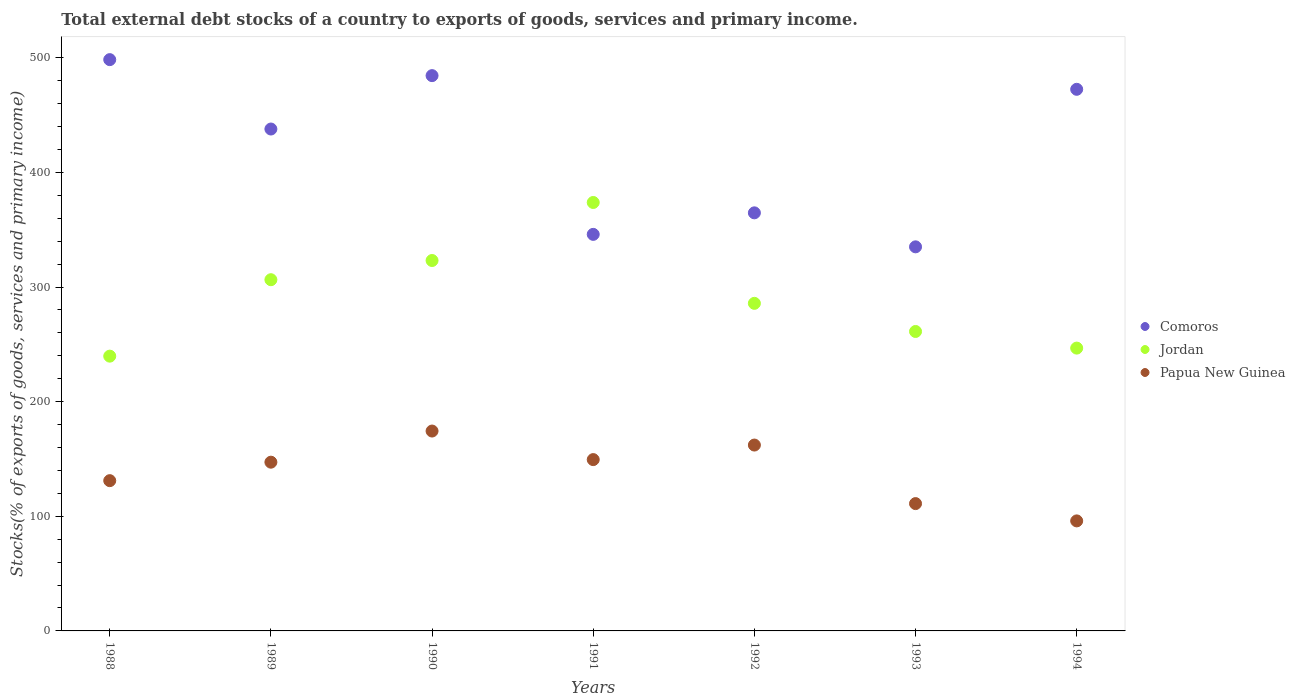How many different coloured dotlines are there?
Provide a short and direct response. 3. What is the total debt stocks in Papua New Guinea in 1994?
Provide a short and direct response. 95.99. Across all years, what is the maximum total debt stocks in Papua New Guinea?
Offer a very short reply. 174.38. Across all years, what is the minimum total debt stocks in Papua New Guinea?
Provide a short and direct response. 95.99. In which year was the total debt stocks in Comoros maximum?
Provide a succinct answer. 1988. In which year was the total debt stocks in Jordan minimum?
Your answer should be compact. 1988. What is the total total debt stocks in Comoros in the graph?
Your response must be concise. 2939.1. What is the difference between the total debt stocks in Comoros in 1992 and that in 1993?
Your response must be concise. 29.66. What is the difference between the total debt stocks in Jordan in 1993 and the total debt stocks in Papua New Guinea in 1988?
Keep it short and to the point. 130.15. What is the average total debt stocks in Jordan per year?
Your answer should be compact. 290.98. In the year 1993, what is the difference between the total debt stocks in Papua New Guinea and total debt stocks in Comoros?
Provide a short and direct response. -224.01. In how many years, is the total debt stocks in Jordan greater than 180 %?
Your answer should be very brief. 7. What is the ratio of the total debt stocks in Jordan in 1988 to that in 1990?
Ensure brevity in your answer.  0.74. Is the total debt stocks in Jordan in 1991 less than that in 1994?
Provide a short and direct response. No. What is the difference between the highest and the second highest total debt stocks in Papua New Guinea?
Keep it short and to the point. 12.22. What is the difference between the highest and the lowest total debt stocks in Jordan?
Give a very brief answer. 134.06. Is the sum of the total debt stocks in Comoros in 1989 and 1992 greater than the maximum total debt stocks in Jordan across all years?
Ensure brevity in your answer.  Yes. Is the total debt stocks in Jordan strictly greater than the total debt stocks in Papua New Guinea over the years?
Keep it short and to the point. Yes. Is the total debt stocks in Comoros strictly less than the total debt stocks in Jordan over the years?
Keep it short and to the point. No. How many years are there in the graph?
Your answer should be compact. 7. What is the difference between two consecutive major ticks on the Y-axis?
Give a very brief answer. 100. Are the values on the major ticks of Y-axis written in scientific E-notation?
Keep it short and to the point. No. Does the graph contain any zero values?
Provide a succinct answer. No. Where does the legend appear in the graph?
Keep it short and to the point. Center right. How are the legend labels stacked?
Offer a very short reply. Vertical. What is the title of the graph?
Your answer should be compact. Total external debt stocks of a country to exports of goods, services and primary income. Does "Pacific island small states" appear as one of the legend labels in the graph?
Make the answer very short. No. What is the label or title of the Y-axis?
Give a very brief answer. Stocks(% of exports of goods, services and primary income). What is the Stocks(% of exports of goods, services and primary income) in Comoros in 1988?
Offer a very short reply. 498.42. What is the Stocks(% of exports of goods, services and primary income) in Jordan in 1988?
Give a very brief answer. 239.73. What is the Stocks(% of exports of goods, services and primary income) in Papua New Guinea in 1988?
Provide a short and direct response. 131.1. What is the Stocks(% of exports of goods, services and primary income) of Comoros in 1989?
Offer a very short reply. 437.88. What is the Stocks(% of exports of goods, services and primary income) of Jordan in 1989?
Provide a succinct answer. 306.42. What is the Stocks(% of exports of goods, services and primary income) in Papua New Guinea in 1989?
Offer a very short reply. 147.21. What is the Stocks(% of exports of goods, services and primary income) in Comoros in 1990?
Your answer should be compact. 484.47. What is the Stocks(% of exports of goods, services and primary income) of Jordan in 1990?
Keep it short and to the point. 323.17. What is the Stocks(% of exports of goods, services and primary income) in Papua New Guinea in 1990?
Give a very brief answer. 174.38. What is the Stocks(% of exports of goods, services and primary income) in Comoros in 1991?
Ensure brevity in your answer.  345.97. What is the Stocks(% of exports of goods, services and primary income) of Jordan in 1991?
Ensure brevity in your answer.  373.79. What is the Stocks(% of exports of goods, services and primary income) in Papua New Guinea in 1991?
Offer a very short reply. 149.47. What is the Stocks(% of exports of goods, services and primary income) in Comoros in 1992?
Your answer should be very brief. 364.75. What is the Stocks(% of exports of goods, services and primary income) of Jordan in 1992?
Provide a succinct answer. 285.8. What is the Stocks(% of exports of goods, services and primary income) in Papua New Guinea in 1992?
Keep it short and to the point. 162.16. What is the Stocks(% of exports of goods, services and primary income) of Comoros in 1993?
Offer a terse response. 335.09. What is the Stocks(% of exports of goods, services and primary income) of Jordan in 1993?
Your answer should be compact. 261.25. What is the Stocks(% of exports of goods, services and primary income) of Papua New Guinea in 1993?
Your answer should be compact. 111.08. What is the Stocks(% of exports of goods, services and primary income) of Comoros in 1994?
Offer a very short reply. 472.53. What is the Stocks(% of exports of goods, services and primary income) of Jordan in 1994?
Provide a short and direct response. 246.74. What is the Stocks(% of exports of goods, services and primary income) of Papua New Guinea in 1994?
Make the answer very short. 95.99. Across all years, what is the maximum Stocks(% of exports of goods, services and primary income) of Comoros?
Make the answer very short. 498.42. Across all years, what is the maximum Stocks(% of exports of goods, services and primary income) in Jordan?
Give a very brief answer. 373.79. Across all years, what is the maximum Stocks(% of exports of goods, services and primary income) in Papua New Guinea?
Give a very brief answer. 174.38. Across all years, what is the minimum Stocks(% of exports of goods, services and primary income) of Comoros?
Give a very brief answer. 335.09. Across all years, what is the minimum Stocks(% of exports of goods, services and primary income) of Jordan?
Give a very brief answer. 239.73. Across all years, what is the minimum Stocks(% of exports of goods, services and primary income) of Papua New Guinea?
Offer a very short reply. 95.99. What is the total Stocks(% of exports of goods, services and primary income) of Comoros in the graph?
Your answer should be very brief. 2939.1. What is the total Stocks(% of exports of goods, services and primary income) in Jordan in the graph?
Make the answer very short. 2036.89. What is the total Stocks(% of exports of goods, services and primary income) in Papua New Guinea in the graph?
Offer a very short reply. 971.4. What is the difference between the Stocks(% of exports of goods, services and primary income) in Comoros in 1988 and that in 1989?
Keep it short and to the point. 60.54. What is the difference between the Stocks(% of exports of goods, services and primary income) of Jordan in 1988 and that in 1989?
Your answer should be compact. -66.69. What is the difference between the Stocks(% of exports of goods, services and primary income) of Papua New Guinea in 1988 and that in 1989?
Keep it short and to the point. -16.11. What is the difference between the Stocks(% of exports of goods, services and primary income) of Comoros in 1988 and that in 1990?
Give a very brief answer. 13.95. What is the difference between the Stocks(% of exports of goods, services and primary income) of Jordan in 1988 and that in 1990?
Provide a short and direct response. -83.44. What is the difference between the Stocks(% of exports of goods, services and primary income) in Papua New Guinea in 1988 and that in 1990?
Your answer should be very brief. -43.28. What is the difference between the Stocks(% of exports of goods, services and primary income) of Comoros in 1988 and that in 1991?
Your answer should be compact. 152.44. What is the difference between the Stocks(% of exports of goods, services and primary income) of Jordan in 1988 and that in 1991?
Provide a succinct answer. -134.06. What is the difference between the Stocks(% of exports of goods, services and primary income) in Papua New Guinea in 1988 and that in 1991?
Your response must be concise. -18.37. What is the difference between the Stocks(% of exports of goods, services and primary income) in Comoros in 1988 and that in 1992?
Your answer should be compact. 133.66. What is the difference between the Stocks(% of exports of goods, services and primary income) of Jordan in 1988 and that in 1992?
Offer a very short reply. -46.07. What is the difference between the Stocks(% of exports of goods, services and primary income) in Papua New Guinea in 1988 and that in 1992?
Your answer should be compact. -31.06. What is the difference between the Stocks(% of exports of goods, services and primary income) of Comoros in 1988 and that in 1993?
Provide a succinct answer. 163.32. What is the difference between the Stocks(% of exports of goods, services and primary income) of Jordan in 1988 and that in 1993?
Give a very brief answer. -21.52. What is the difference between the Stocks(% of exports of goods, services and primary income) of Papua New Guinea in 1988 and that in 1993?
Your response must be concise. 20.01. What is the difference between the Stocks(% of exports of goods, services and primary income) in Comoros in 1988 and that in 1994?
Offer a terse response. 25.89. What is the difference between the Stocks(% of exports of goods, services and primary income) of Jordan in 1988 and that in 1994?
Provide a succinct answer. -7.01. What is the difference between the Stocks(% of exports of goods, services and primary income) of Papua New Guinea in 1988 and that in 1994?
Provide a succinct answer. 35.1. What is the difference between the Stocks(% of exports of goods, services and primary income) of Comoros in 1989 and that in 1990?
Give a very brief answer. -46.59. What is the difference between the Stocks(% of exports of goods, services and primary income) in Jordan in 1989 and that in 1990?
Keep it short and to the point. -16.75. What is the difference between the Stocks(% of exports of goods, services and primary income) in Papua New Guinea in 1989 and that in 1990?
Your response must be concise. -27.17. What is the difference between the Stocks(% of exports of goods, services and primary income) in Comoros in 1989 and that in 1991?
Keep it short and to the point. 91.9. What is the difference between the Stocks(% of exports of goods, services and primary income) in Jordan in 1989 and that in 1991?
Your answer should be compact. -67.38. What is the difference between the Stocks(% of exports of goods, services and primary income) of Papua New Guinea in 1989 and that in 1991?
Give a very brief answer. -2.26. What is the difference between the Stocks(% of exports of goods, services and primary income) in Comoros in 1989 and that in 1992?
Your response must be concise. 73.13. What is the difference between the Stocks(% of exports of goods, services and primary income) in Jordan in 1989 and that in 1992?
Give a very brief answer. 20.62. What is the difference between the Stocks(% of exports of goods, services and primary income) in Papua New Guinea in 1989 and that in 1992?
Keep it short and to the point. -14.94. What is the difference between the Stocks(% of exports of goods, services and primary income) of Comoros in 1989 and that in 1993?
Your answer should be compact. 102.79. What is the difference between the Stocks(% of exports of goods, services and primary income) of Jordan in 1989 and that in 1993?
Your answer should be compact. 45.17. What is the difference between the Stocks(% of exports of goods, services and primary income) of Papua New Guinea in 1989 and that in 1993?
Give a very brief answer. 36.13. What is the difference between the Stocks(% of exports of goods, services and primary income) of Comoros in 1989 and that in 1994?
Your answer should be compact. -34.65. What is the difference between the Stocks(% of exports of goods, services and primary income) in Jordan in 1989 and that in 1994?
Keep it short and to the point. 59.67. What is the difference between the Stocks(% of exports of goods, services and primary income) in Papua New Guinea in 1989 and that in 1994?
Offer a terse response. 51.22. What is the difference between the Stocks(% of exports of goods, services and primary income) of Comoros in 1990 and that in 1991?
Provide a short and direct response. 138.49. What is the difference between the Stocks(% of exports of goods, services and primary income) in Jordan in 1990 and that in 1991?
Make the answer very short. -50.63. What is the difference between the Stocks(% of exports of goods, services and primary income) in Papua New Guinea in 1990 and that in 1991?
Your answer should be very brief. 24.91. What is the difference between the Stocks(% of exports of goods, services and primary income) in Comoros in 1990 and that in 1992?
Offer a terse response. 119.71. What is the difference between the Stocks(% of exports of goods, services and primary income) in Jordan in 1990 and that in 1992?
Ensure brevity in your answer.  37.37. What is the difference between the Stocks(% of exports of goods, services and primary income) in Papua New Guinea in 1990 and that in 1992?
Offer a terse response. 12.22. What is the difference between the Stocks(% of exports of goods, services and primary income) in Comoros in 1990 and that in 1993?
Offer a very short reply. 149.37. What is the difference between the Stocks(% of exports of goods, services and primary income) in Jordan in 1990 and that in 1993?
Your response must be concise. 61.92. What is the difference between the Stocks(% of exports of goods, services and primary income) of Papua New Guinea in 1990 and that in 1993?
Keep it short and to the point. 63.3. What is the difference between the Stocks(% of exports of goods, services and primary income) in Comoros in 1990 and that in 1994?
Offer a terse response. 11.94. What is the difference between the Stocks(% of exports of goods, services and primary income) in Jordan in 1990 and that in 1994?
Your answer should be compact. 76.42. What is the difference between the Stocks(% of exports of goods, services and primary income) in Papua New Guinea in 1990 and that in 1994?
Give a very brief answer. 78.39. What is the difference between the Stocks(% of exports of goods, services and primary income) in Comoros in 1991 and that in 1992?
Offer a very short reply. -18.78. What is the difference between the Stocks(% of exports of goods, services and primary income) of Jordan in 1991 and that in 1992?
Your response must be concise. 88. What is the difference between the Stocks(% of exports of goods, services and primary income) of Papua New Guinea in 1991 and that in 1992?
Your answer should be compact. -12.69. What is the difference between the Stocks(% of exports of goods, services and primary income) of Comoros in 1991 and that in 1993?
Offer a terse response. 10.88. What is the difference between the Stocks(% of exports of goods, services and primary income) in Jordan in 1991 and that in 1993?
Provide a short and direct response. 112.55. What is the difference between the Stocks(% of exports of goods, services and primary income) in Papua New Guinea in 1991 and that in 1993?
Ensure brevity in your answer.  38.39. What is the difference between the Stocks(% of exports of goods, services and primary income) of Comoros in 1991 and that in 1994?
Your answer should be compact. -126.55. What is the difference between the Stocks(% of exports of goods, services and primary income) in Jordan in 1991 and that in 1994?
Keep it short and to the point. 127.05. What is the difference between the Stocks(% of exports of goods, services and primary income) in Papua New Guinea in 1991 and that in 1994?
Your response must be concise. 53.47. What is the difference between the Stocks(% of exports of goods, services and primary income) of Comoros in 1992 and that in 1993?
Provide a succinct answer. 29.66. What is the difference between the Stocks(% of exports of goods, services and primary income) of Jordan in 1992 and that in 1993?
Offer a terse response. 24.55. What is the difference between the Stocks(% of exports of goods, services and primary income) in Papua New Guinea in 1992 and that in 1993?
Your answer should be very brief. 51.07. What is the difference between the Stocks(% of exports of goods, services and primary income) in Comoros in 1992 and that in 1994?
Offer a terse response. -107.78. What is the difference between the Stocks(% of exports of goods, services and primary income) of Jordan in 1992 and that in 1994?
Ensure brevity in your answer.  39.05. What is the difference between the Stocks(% of exports of goods, services and primary income) in Papua New Guinea in 1992 and that in 1994?
Provide a short and direct response. 66.16. What is the difference between the Stocks(% of exports of goods, services and primary income) of Comoros in 1993 and that in 1994?
Ensure brevity in your answer.  -137.44. What is the difference between the Stocks(% of exports of goods, services and primary income) of Jordan in 1993 and that in 1994?
Your response must be concise. 14.51. What is the difference between the Stocks(% of exports of goods, services and primary income) in Papua New Guinea in 1993 and that in 1994?
Offer a very short reply. 15.09. What is the difference between the Stocks(% of exports of goods, services and primary income) in Comoros in 1988 and the Stocks(% of exports of goods, services and primary income) in Jordan in 1989?
Keep it short and to the point. 192. What is the difference between the Stocks(% of exports of goods, services and primary income) in Comoros in 1988 and the Stocks(% of exports of goods, services and primary income) in Papua New Guinea in 1989?
Ensure brevity in your answer.  351.2. What is the difference between the Stocks(% of exports of goods, services and primary income) of Jordan in 1988 and the Stocks(% of exports of goods, services and primary income) of Papua New Guinea in 1989?
Provide a succinct answer. 92.52. What is the difference between the Stocks(% of exports of goods, services and primary income) in Comoros in 1988 and the Stocks(% of exports of goods, services and primary income) in Jordan in 1990?
Your response must be concise. 175.25. What is the difference between the Stocks(% of exports of goods, services and primary income) in Comoros in 1988 and the Stocks(% of exports of goods, services and primary income) in Papua New Guinea in 1990?
Keep it short and to the point. 324.03. What is the difference between the Stocks(% of exports of goods, services and primary income) in Jordan in 1988 and the Stocks(% of exports of goods, services and primary income) in Papua New Guinea in 1990?
Make the answer very short. 65.35. What is the difference between the Stocks(% of exports of goods, services and primary income) of Comoros in 1988 and the Stocks(% of exports of goods, services and primary income) of Jordan in 1991?
Give a very brief answer. 124.62. What is the difference between the Stocks(% of exports of goods, services and primary income) in Comoros in 1988 and the Stocks(% of exports of goods, services and primary income) in Papua New Guinea in 1991?
Make the answer very short. 348.95. What is the difference between the Stocks(% of exports of goods, services and primary income) in Jordan in 1988 and the Stocks(% of exports of goods, services and primary income) in Papua New Guinea in 1991?
Provide a short and direct response. 90.26. What is the difference between the Stocks(% of exports of goods, services and primary income) in Comoros in 1988 and the Stocks(% of exports of goods, services and primary income) in Jordan in 1992?
Offer a terse response. 212.62. What is the difference between the Stocks(% of exports of goods, services and primary income) in Comoros in 1988 and the Stocks(% of exports of goods, services and primary income) in Papua New Guinea in 1992?
Offer a very short reply. 336.26. What is the difference between the Stocks(% of exports of goods, services and primary income) in Jordan in 1988 and the Stocks(% of exports of goods, services and primary income) in Papua New Guinea in 1992?
Your answer should be compact. 77.57. What is the difference between the Stocks(% of exports of goods, services and primary income) in Comoros in 1988 and the Stocks(% of exports of goods, services and primary income) in Jordan in 1993?
Ensure brevity in your answer.  237.17. What is the difference between the Stocks(% of exports of goods, services and primary income) in Comoros in 1988 and the Stocks(% of exports of goods, services and primary income) in Papua New Guinea in 1993?
Offer a very short reply. 387.33. What is the difference between the Stocks(% of exports of goods, services and primary income) in Jordan in 1988 and the Stocks(% of exports of goods, services and primary income) in Papua New Guinea in 1993?
Ensure brevity in your answer.  128.65. What is the difference between the Stocks(% of exports of goods, services and primary income) of Comoros in 1988 and the Stocks(% of exports of goods, services and primary income) of Jordan in 1994?
Provide a short and direct response. 251.67. What is the difference between the Stocks(% of exports of goods, services and primary income) in Comoros in 1988 and the Stocks(% of exports of goods, services and primary income) in Papua New Guinea in 1994?
Give a very brief answer. 402.42. What is the difference between the Stocks(% of exports of goods, services and primary income) in Jordan in 1988 and the Stocks(% of exports of goods, services and primary income) in Papua New Guinea in 1994?
Your answer should be compact. 143.74. What is the difference between the Stocks(% of exports of goods, services and primary income) in Comoros in 1989 and the Stocks(% of exports of goods, services and primary income) in Jordan in 1990?
Your response must be concise. 114.71. What is the difference between the Stocks(% of exports of goods, services and primary income) in Comoros in 1989 and the Stocks(% of exports of goods, services and primary income) in Papua New Guinea in 1990?
Make the answer very short. 263.5. What is the difference between the Stocks(% of exports of goods, services and primary income) of Jordan in 1989 and the Stocks(% of exports of goods, services and primary income) of Papua New Guinea in 1990?
Keep it short and to the point. 132.03. What is the difference between the Stocks(% of exports of goods, services and primary income) in Comoros in 1989 and the Stocks(% of exports of goods, services and primary income) in Jordan in 1991?
Keep it short and to the point. 64.08. What is the difference between the Stocks(% of exports of goods, services and primary income) of Comoros in 1989 and the Stocks(% of exports of goods, services and primary income) of Papua New Guinea in 1991?
Your response must be concise. 288.41. What is the difference between the Stocks(% of exports of goods, services and primary income) of Jordan in 1989 and the Stocks(% of exports of goods, services and primary income) of Papua New Guinea in 1991?
Give a very brief answer. 156.95. What is the difference between the Stocks(% of exports of goods, services and primary income) in Comoros in 1989 and the Stocks(% of exports of goods, services and primary income) in Jordan in 1992?
Give a very brief answer. 152.08. What is the difference between the Stocks(% of exports of goods, services and primary income) in Comoros in 1989 and the Stocks(% of exports of goods, services and primary income) in Papua New Guinea in 1992?
Make the answer very short. 275.72. What is the difference between the Stocks(% of exports of goods, services and primary income) of Jordan in 1989 and the Stocks(% of exports of goods, services and primary income) of Papua New Guinea in 1992?
Your answer should be very brief. 144.26. What is the difference between the Stocks(% of exports of goods, services and primary income) of Comoros in 1989 and the Stocks(% of exports of goods, services and primary income) of Jordan in 1993?
Your answer should be very brief. 176.63. What is the difference between the Stocks(% of exports of goods, services and primary income) of Comoros in 1989 and the Stocks(% of exports of goods, services and primary income) of Papua New Guinea in 1993?
Ensure brevity in your answer.  326.79. What is the difference between the Stocks(% of exports of goods, services and primary income) in Jordan in 1989 and the Stocks(% of exports of goods, services and primary income) in Papua New Guinea in 1993?
Provide a short and direct response. 195.33. What is the difference between the Stocks(% of exports of goods, services and primary income) of Comoros in 1989 and the Stocks(% of exports of goods, services and primary income) of Jordan in 1994?
Ensure brevity in your answer.  191.14. What is the difference between the Stocks(% of exports of goods, services and primary income) in Comoros in 1989 and the Stocks(% of exports of goods, services and primary income) in Papua New Guinea in 1994?
Give a very brief answer. 341.88. What is the difference between the Stocks(% of exports of goods, services and primary income) in Jordan in 1989 and the Stocks(% of exports of goods, services and primary income) in Papua New Guinea in 1994?
Your answer should be very brief. 210.42. What is the difference between the Stocks(% of exports of goods, services and primary income) in Comoros in 1990 and the Stocks(% of exports of goods, services and primary income) in Jordan in 1991?
Give a very brief answer. 110.67. What is the difference between the Stocks(% of exports of goods, services and primary income) in Comoros in 1990 and the Stocks(% of exports of goods, services and primary income) in Papua New Guinea in 1991?
Offer a very short reply. 335. What is the difference between the Stocks(% of exports of goods, services and primary income) in Jordan in 1990 and the Stocks(% of exports of goods, services and primary income) in Papua New Guinea in 1991?
Offer a very short reply. 173.7. What is the difference between the Stocks(% of exports of goods, services and primary income) in Comoros in 1990 and the Stocks(% of exports of goods, services and primary income) in Jordan in 1992?
Offer a terse response. 198.67. What is the difference between the Stocks(% of exports of goods, services and primary income) of Comoros in 1990 and the Stocks(% of exports of goods, services and primary income) of Papua New Guinea in 1992?
Your answer should be compact. 322.31. What is the difference between the Stocks(% of exports of goods, services and primary income) of Jordan in 1990 and the Stocks(% of exports of goods, services and primary income) of Papua New Guinea in 1992?
Give a very brief answer. 161.01. What is the difference between the Stocks(% of exports of goods, services and primary income) of Comoros in 1990 and the Stocks(% of exports of goods, services and primary income) of Jordan in 1993?
Give a very brief answer. 223.22. What is the difference between the Stocks(% of exports of goods, services and primary income) in Comoros in 1990 and the Stocks(% of exports of goods, services and primary income) in Papua New Guinea in 1993?
Give a very brief answer. 373.38. What is the difference between the Stocks(% of exports of goods, services and primary income) of Jordan in 1990 and the Stocks(% of exports of goods, services and primary income) of Papua New Guinea in 1993?
Provide a succinct answer. 212.08. What is the difference between the Stocks(% of exports of goods, services and primary income) of Comoros in 1990 and the Stocks(% of exports of goods, services and primary income) of Jordan in 1994?
Make the answer very short. 237.72. What is the difference between the Stocks(% of exports of goods, services and primary income) of Comoros in 1990 and the Stocks(% of exports of goods, services and primary income) of Papua New Guinea in 1994?
Keep it short and to the point. 388.47. What is the difference between the Stocks(% of exports of goods, services and primary income) in Jordan in 1990 and the Stocks(% of exports of goods, services and primary income) in Papua New Guinea in 1994?
Your response must be concise. 227.17. What is the difference between the Stocks(% of exports of goods, services and primary income) of Comoros in 1991 and the Stocks(% of exports of goods, services and primary income) of Jordan in 1992?
Your answer should be very brief. 60.18. What is the difference between the Stocks(% of exports of goods, services and primary income) in Comoros in 1991 and the Stocks(% of exports of goods, services and primary income) in Papua New Guinea in 1992?
Your response must be concise. 183.82. What is the difference between the Stocks(% of exports of goods, services and primary income) of Jordan in 1991 and the Stocks(% of exports of goods, services and primary income) of Papua New Guinea in 1992?
Offer a very short reply. 211.63. What is the difference between the Stocks(% of exports of goods, services and primary income) of Comoros in 1991 and the Stocks(% of exports of goods, services and primary income) of Jordan in 1993?
Give a very brief answer. 84.73. What is the difference between the Stocks(% of exports of goods, services and primary income) of Comoros in 1991 and the Stocks(% of exports of goods, services and primary income) of Papua New Guinea in 1993?
Your answer should be compact. 234.89. What is the difference between the Stocks(% of exports of goods, services and primary income) of Jordan in 1991 and the Stocks(% of exports of goods, services and primary income) of Papua New Guinea in 1993?
Keep it short and to the point. 262.71. What is the difference between the Stocks(% of exports of goods, services and primary income) in Comoros in 1991 and the Stocks(% of exports of goods, services and primary income) in Jordan in 1994?
Offer a terse response. 99.23. What is the difference between the Stocks(% of exports of goods, services and primary income) in Comoros in 1991 and the Stocks(% of exports of goods, services and primary income) in Papua New Guinea in 1994?
Your answer should be compact. 249.98. What is the difference between the Stocks(% of exports of goods, services and primary income) of Jordan in 1991 and the Stocks(% of exports of goods, services and primary income) of Papua New Guinea in 1994?
Offer a very short reply. 277.8. What is the difference between the Stocks(% of exports of goods, services and primary income) of Comoros in 1992 and the Stocks(% of exports of goods, services and primary income) of Jordan in 1993?
Offer a very short reply. 103.5. What is the difference between the Stocks(% of exports of goods, services and primary income) of Comoros in 1992 and the Stocks(% of exports of goods, services and primary income) of Papua New Guinea in 1993?
Your answer should be compact. 253.67. What is the difference between the Stocks(% of exports of goods, services and primary income) of Jordan in 1992 and the Stocks(% of exports of goods, services and primary income) of Papua New Guinea in 1993?
Keep it short and to the point. 174.71. What is the difference between the Stocks(% of exports of goods, services and primary income) in Comoros in 1992 and the Stocks(% of exports of goods, services and primary income) in Jordan in 1994?
Make the answer very short. 118.01. What is the difference between the Stocks(% of exports of goods, services and primary income) of Comoros in 1992 and the Stocks(% of exports of goods, services and primary income) of Papua New Guinea in 1994?
Provide a short and direct response. 268.76. What is the difference between the Stocks(% of exports of goods, services and primary income) in Jordan in 1992 and the Stocks(% of exports of goods, services and primary income) in Papua New Guinea in 1994?
Your answer should be compact. 189.8. What is the difference between the Stocks(% of exports of goods, services and primary income) of Comoros in 1993 and the Stocks(% of exports of goods, services and primary income) of Jordan in 1994?
Make the answer very short. 88.35. What is the difference between the Stocks(% of exports of goods, services and primary income) of Comoros in 1993 and the Stocks(% of exports of goods, services and primary income) of Papua New Guinea in 1994?
Offer a very short reply. 239.1. What is the difference between the Stocks(% of exports of goods, services and primary income) of Jordan in 1993 and the Stocks(% of exports of goods, services and primary income) of Papua New Guinea in 1994?
Your response must be concise. 165.25. What is the average Stocks(% of exports of goods, services and primary income) of Comoros per year?
Your answer should be very brief. 419.87. What is the average Stocks(% of exports of goods, services and primary income) of Jordan per year?
Ensure brevity in your answer.  290.98. What is the average Stocks(% of exports of goods, services and primary income) of Papua New Guinea per year?
Your answer should be compact. 138.77. In the year 1988, what is the difference between the Stocks(% of exports of goods, services and primary income) of Comoros and Stocks(% of exports of goods, services and primary income) of Jordan?
Your answer should be compact. 258.69. In the year 1988, what is the difference between the Stocks(% of exports of goods, services and primary income) of Comoros and Stocks(% of exports of goods, services and primary income) of Papua New Guinea?
Offer a terse response. 367.32. In the year 1988, what is the difference between the Stocks(% of exports of goods, services and primary income) in Jordan and Stocks(% of exports of goods, services and primary income) in Papua New Guinea?
Your answer should be compact. 108.63. In the year 1989, what is the difference between the Stocks(% of exports of goods, services and primary income) in Comoros and Stocks(% of exports of goods, services and primary income) in Jordan?
Ensure brevity in your answer.  131.46. In the year 1989, what is the difference between the Stocks(% of exports of goods, services and primary income) in Comoros and Stocks(% of exports of goods, services and primary income) in Papua New Guinea?
Make the answer very short. 290.66. In the year 1989, what is the difference between the Stocks(% of exports of goods, services and primary income) in Jordan and Stocks(% of exports of goods, services and primary income) in Papua New Guinea?
Make the answer very short. 159.2. In the year 1990, what is the difference between the Stocks(% of exports of goods, services and primary income) of Comoros and Stocks(% of exports of goods, services and primary income) of Jordan?
Make the answer very short. 161.3. In the year 1990, what is the difference between the Stocks(% of exports of goods, services and primary income) in Comoros and Stocks(% of exports of goods, services and primary income) in Papua New Guinea?
Offer a terse response. 310.08. In the year 1990, what is the difference between the Stocks(% of exports of goods, services and primary income) in Jordan and Stocks(% of exports of goods, services and primary income) in Papua New Guinea?
Give a very brief answer. 148.78. In the year 1991, what is the difference between the Stocks(% of exports of goods, services and primary income) in Comoros and Stocks(% of exports of goods, services and primary income) in Jordan?
Your answer should be very brief. -27.82. In the year 1991, what is the difference between the Stocks(% of exports of goods, services and primary income) in Comoros and Stocks(% of exports of goods, services and primary income) in Papua New Guinea?
Make the answer very short. 196.5. In the year 1991, what is the difference between the Stocks(% of exports of goods, services and primary income) of Jordan and Stocks(% of exports of goods, services and primary income) of Papua New Guinea?
Your response must be concise. 224.32. In the year 1992, what is the difference between the Stocks(% of exports of goods, services and primary income) of Comoros and Stocks(% of exports of goods, services and primary income) of Jordan?
Your answer should be very brief. 78.95. In the year 1992, what is the difference between the Stocks(% of exports of goods, services and primary income) in Comoros and Stocks(% of exports of goods, services and primary income) in Papua New Guinea?
Offer a very short reply. 202.59. In the year 1992, what is the difference between the Stocks(% of exports of goods, services and primary income) in Jordan and Stocks(% of exports of goods, services and primary income) in Papua New Guinea?
Your response must be concise. 123.64. In the year 1993, what is the difference between the Stocks(% of exports of goods, services and primary income) of Comoros and Stocks(% of exports of goods, services and primary income) of Jordan?
Give a very brief answer. 73.84. In the year 1993, what is the difference between the Stocks(% of exports of goods, services and primary income) in Comoros and Stocks(% of exports of goods, services and primary income) in Papua New Guinea?
Your answer should be very brief. 224.01. In the year 1993, what is the difference between the Stocks(% of exports of goods, services and primary income) of Jordan and Stocks(% of exports of goods, services and primary income) of Papua New Guinea?
Your answer should be compact. 150.16. In the year 1994, what is the difference between the Stocks(% of exports of goods, services and primary income) of Comoros and Stocks(% of exports of goods, services and primary income) of Jordan?
Your response must be concise. 225.79. In the year 1994, what is the difference between the Stocks(% of exports of goods, services and primary income) in Comoros and Stocks(% of exports of goods, services and primary income) in Papua New Guinea?
Your response must be concise. 376.53. In the year 1994, what is the difference between the Stocks(% of exports of goods, services and primary income) of Jordan and Stocks(% of exports of goods, services and primary income) of Papua New Guinea?
Offer a very short reply. 150.75. What is the ratio of the Stocks(% of exports of goods, services and primary income) of Comoros in 1988 to that in 1989?
Provide a succinct answer. 1.14. What is the ratio of the Stocks(% of exports of goods, services and primary income) of Jordan in 1988 to that in 1989?
Provide a short and direct response. 0.78. What is the ratio of the Stocks(% of exports of goods, services and primary income) in Papua New Guinea in 1988 to that in 1989?
Offer a terse response. 0.89. What is the ratio of the Stocks(% of exports of goods, services and primary income) in Comoros in 1988 to that in 1990?
Keep it short and to the point. 1.03. What is the ratio of the Stocks(% of exports of goods, services and primary income) of Jordan in 1988 to that in 1990?
Offer a very short reply. 0.74. What is the ratio of the Stocks(% of exports of goods, services and primary income) in Papua New Guinea in 1988 to that in 1990?
Keep it short and to the point. 0.75. What is the ratio of the Stocks(% of exports of goods, services and primary income) in Comoros in 1988 to that in 1991?
Keep it short and to the point. 1.44. What is the ratio of the Stocks(% of exports of goods, services and primary income) in Jordan in 1988 to that in 1991?
Provide a succinct answer. 0.64. What is the ratio of the Stocks(% of exports of goods, services and primary income) in Papua New Guinea in 1988 to that in 1991?
Your answer should be very brief. 0.88. What is the ratio of the Stocks(% of exports of goods, services and primary income) of Comoros in 1988 to that in 1992?
Offer a terse response. 1.37. What is the ratio of the Stocks(% of exports of goods, services and primary income) in Jordan in 1988 to that in 1992?
Keep it short and to the point. 0.84. What is the ratio of the Stocks(% of exports of goods, services and primary income) of Papua New Guinea in 1988 to that in 1992?
Ensure brevity in your answer.  0.81. What is the ratio of the Stocks(% of exports of goods, services and primary income) in Comoros in 1988 to that in 1993?
Your answer should be compact. 1.49. What is the ratio of the Stocks(% of exports of goods, services and primary income) in Jordan in 1988 to that in 1993?
Provide a short and direct response. 0.92. What is the ratio of the Stocks(% of exports of goods, services and primary income) in Papua New Guinea in 1988 to that in 1993?
Give a very brief answer. 1.18. What is the ratio of the Stocks(% of exports of goods, services and primary income) in Comoros in 1988 to that in 1994?
Make the answer very short. 1.05. What is the ratio of the Stocks(% of exports of goods, services and primary income) of Jordan in 1988 to that in 1994?
Ensure brevity in your answer.  0.97. What is the ratio of the Stocks(% of exports of goods, services and primary income) of Papua New Guinea in 1988 to that in 1994?
Offer a terse response. 1.37. What is the ratio of the Stocks(% of exports of goods, services and primary income) of Comoros in 1989 to that in 1990?
Your answer should be compact. 0.9. What is the ratio of the Stocks(% of exports of goods, services and primary income) of Jordan in 1989 to that in 1990?
Provide a short and direct response. 0.95. What is the ratio of the Stocks(% of exports of goods, services and primary income) in Papua New Guinea in 1989 to that in 1990?
Your answer should be compact. 0.84. What is the ratio of the Stocks(% of exports of goods, services and primary income) in Comoros in 1989 to that in 1991?
Your answer should be compact. 1.27. What is the ratio of the Stocks(% of exports of goods, services and primary income) of Jordan in 1989 to that in 1991?
Provide a short and direct response. 0.82. What is the ratio of the Stocks(% of exports of goods, services and primary income) of Papua New Guinea in 1989 to that in 1991?
Offer a very short reply. 0.98. What is the ratio of the Stocks(% of exports of goods, services and primary income) of Comoros in 1989 to that in 1992?
Give a very brief answer. 1.2. What is the ratio of the Stocks(% of exports of goods, services and primary income) of Jordan in 1989 to that in 1992?
Make the answer very short. 1.07. What is the ratio of the Stocks(% of exports of goods, services and primary income) of Papua New Guinea in 1989 to that in 1992?
Keep it short and to the point. 0.91. What is the ratio of the Stocks(% of exports of goods, services and primary income) of Comoros in 1989 to that in 1993?
Offer a very short reply. 1.31. What is the ratio of the Stocks(% of exports of goods, services and primary income) of Jordan in 1989 to that in 1993?
Your response must be concise. 1.17. What is the ratio of the Stocks(% of exports of goods, services and primary income) of Papua New Guinea in 1989 to that in 1993?
Offer a very short reply. 1.33. What is the ratio of the Stocks(% of exports of goods, services and primary income) of Comoros in 1989 to that in 1994?
Your answer should be very brief. 0.93. What is the ratio of the Stocks(% of exports of goods, services and primary income) of Jordan in 1989 to that in 1994?
Offer a very short reply. 1.24. What is the ratio of the Stocks(% of exports of goods, services and primary income) of Papua New Guinea in 1989 to that in 1994?
Make the answer very short. 1.53. What is the ratio of the Stocks(% of exports of goods, services and primary income) in Comoros in 1990 to that in 1991?
Keep it short and to the point. 1.4. What is the ratio of the Stocks(% of exports of goods, services and primary income) in Jordan in 1990 to that in 1991?
Offer a terse response. 0.86. What is the ratio of the Stocks(% of exports of goods, services and primary income) of Papua New Guinea in 1990 to that in 1991?
Make the answer very short. 1.17. What is the ratio of the Stocks(% of exports of goods, services and primary income) in Comoros in 1990 to that in 1992?
Give a very brief answer. 1.33. What is the ratio of the Stocks(% of exports of goods, services and primary income) of Jordan in 1990 to that in 1992?
Offer a very short reply. 1.13. What is the ratio of the Stocks(% of exports of goods, services and primary income) of Papua New Guinea in 1990 to that in 1992?
Make the answer very short. 1.08. What is the ratio of the Stocks(% of exports of goods, services and primary income) of Comoros in 1990 to that in 1993?
Offer a terse response. 1.45. What is the ratio of the Stocks(% of exports of goods, services and primary income) in Jordan in 1990 to that in 1993?
Offer a terse response. 1.24. What is the ratio of the Stocks(% of exports of goods, services and primary income) in Papua New Guinea in 1990 to that in 1993?
Keep it short and to the point. 1.57. What is the ratio of the Stocks(% of exports of goods, services and primary income) in Comoros in 1990 to that in 1994?
Keep it short and to the point. 1.03. What is the ratio of the Stocks(% of exports of goods, services and primary income) of Jordan in 1990 to that in 1994?
Provide a succinct answer. 1.31. What is the ratio of the Stocks(% of exports of goods, services and primary income) of Papua New Guinea in 1990 to that in 1994?
Your answer should be compact. 1.82. What is the ratio of the Stocks(% of exports of goods, services and primary income) of Comoros in 1991 to that in 1992?
Make the answer very short. 0.95. What is the ratio of the Stocks(% of exports of goods, services and primary income) of Jordan in 1991 to that in 1992?
Ensure brevity in your answer.  1.31. What is the ratio of the Stocks(% of exports of goods, services and primary income) in Papua New Guinea in 1991 to that in 1992?
Your answer should be compact. 0.92. What is the ratio of the Stocks(% of exports of goods, services and primary income) of Comoros in 1991 to that in 1993?
Give a very brief answer. 1.03. What is the ratio of the Stocks(% of exports of goods, services and primary income) in Jordan in 1991 to that in 1993?
Your response must be concise. 1.43. What is the ratio of the Stocks(% of exports of goods, services and primary income) of Papua New Guinea in 1991 to that in 1993?
Give a very brief answer. 1.35. What is the ratio of the Stocks(% of exports of goods, services and primary income) in Comoros in 1991 to that in 1994?
Your response must be concise. 0.73. What is the ratio of the Stocks(% of exports of goods, services and primary income) in Jordan in 1991 to that in 1994?
Your answer should be very brief. 1.51. What is the ratio of the Stocks(% of exports of goods, services and primary income) of Papua New Guinea in 1991 to that in 1994?
Provide a short and direct response. 1.56. What is the ratio of the Stocks(% of exports of goods, services and primary income) in Comoros in 1992 to that in 1993?
Keep it short and to the point. 1.09. What is the ratio of the Stocks(% of exports of goods, services and primary income) of Jordan in 1992 to that in 1993?
Provide a succinct answer. 1.09. What is the ratio of the Stocks(% of exports of goods, services and primary income) in Papua New Guinea in 1992 to that in 1993?
Provide a succinct answer. 1.46. What is the ratio of the Stocks(% of exports of goods, services and primary income) in Comoros in 1992 to that in 1994?
Your answer should be very brief. 0.77. What is the ratio of the Stocks(% of exports of goods, services and primary income) of Jordan in 1992 to that in 1994?
Keep it short and to the point. 1.16. What is the ratio of the Stocks(% of exports of goods, services and primary income) in Papua New Guinea in 1992 to that in 1994?
Your answer should be very brief. 1.69. What is the ratio of the Stocks(% of exports of goods, services and primary income) in Comoros in 1993 to that in 1994?
Offer a terse response. 0.71. What is the ratio of the Stocks(% of exports of goods, services and primary income) of Jordan in 1993 to that in 1994?
Offer a terse response. 1.06. What is the ratio of the Stocks(% of exports of goods, services and primary income) of Papua New Guinea in 1993 to that in 1994?
Offer a very short reply. 1.16. What is the difference between the highest and the second highest Stocks(% of exports of goods, services and primary income) of Comoros?
Offer a very short reply. 13.95. What is the difference between the highest and the second highest Stocks(% of exports of goods, services and primary income) of Jordan?
Keep it short and to the point. 50.63. What is the difference between the highest and the second highest Stocks(% of exports of goods, services and primary income) of Papua New Guinea?
Your response must be concise. 12.22. What is the difference between the highest and the lowest Stocks(% of exports of goods, services and primary income) in Comoros?
Your answer should be compact. 163.32. What is the difference between the highest and the lowest Stocks(% of exports of goods, services and primary income) of Jordan?
Provide a short and direct response. 134.06. What is the difference between the highest and the lowest Stocks(% of exports of goods, services and primary income) in Papua New Guinea?
Make the answer very short. 78.39. 